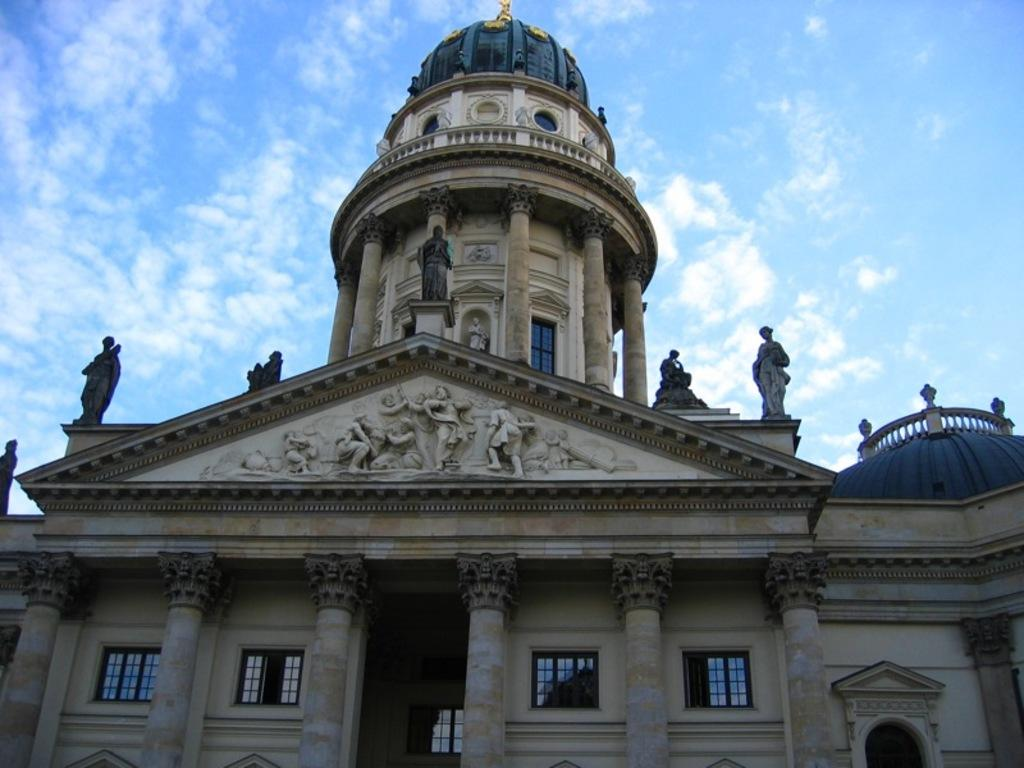What type of structure is in the image? There is a building in the image. What features can be seen on the building? The building has windows, pillars, and sculptures. What is visible in the background of the image? The sky is visible in the background of the image. What can be observed in the sky? Clouds are present in the sky. What type of oil is being used to maintain the sculptures on the building? There is no mention of oil being used to maintain the sculptures on the building in the image. 